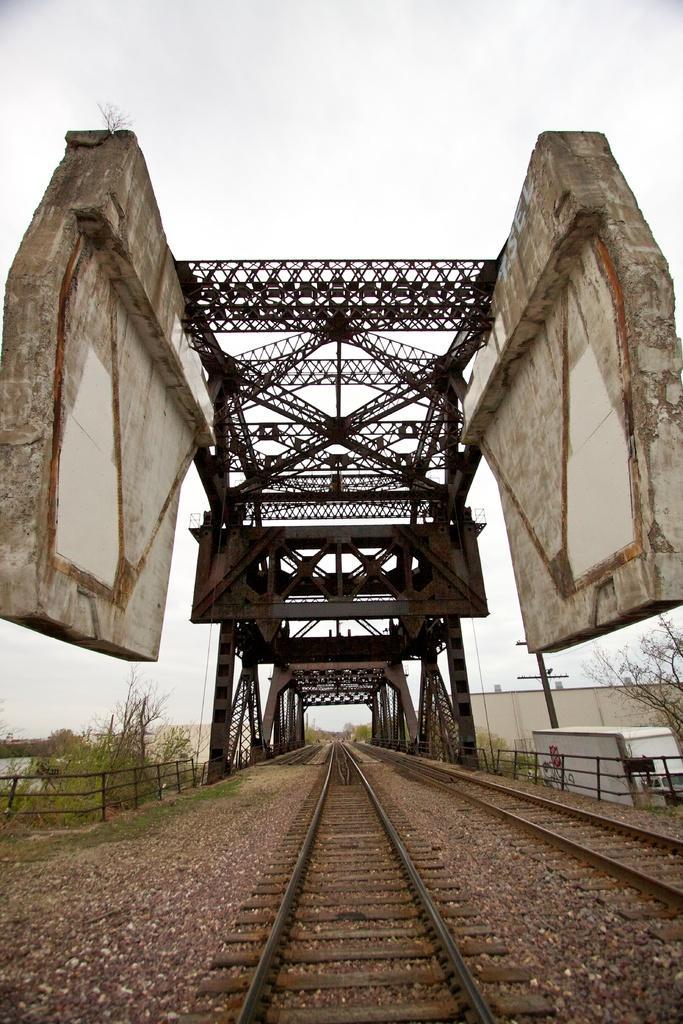Please provide a concise description of this image. This picture shows couple of railway tracks and we see a bridge and few trees and a building and we see a cloudy sky. 